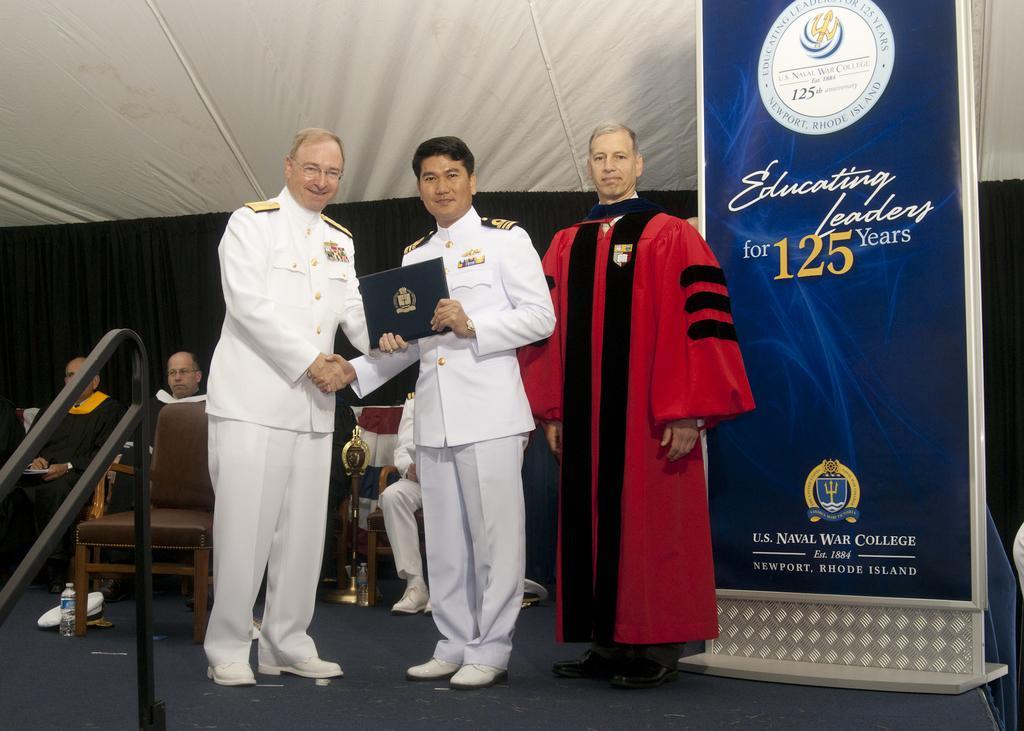In one or two sentences, can you explain what this image depicts? In this picture we can see there are three people standing on the path and some people are sitting on chairs. Behind the people there is a banner and a black cloth. 